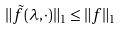<formula> <loc_0><loc_0><loc_500><loc_500>\| \tilde { f } ( \lambda , \cdot ) \| _ { 1 } \leq \| f \| _ { 1 }</formula> 